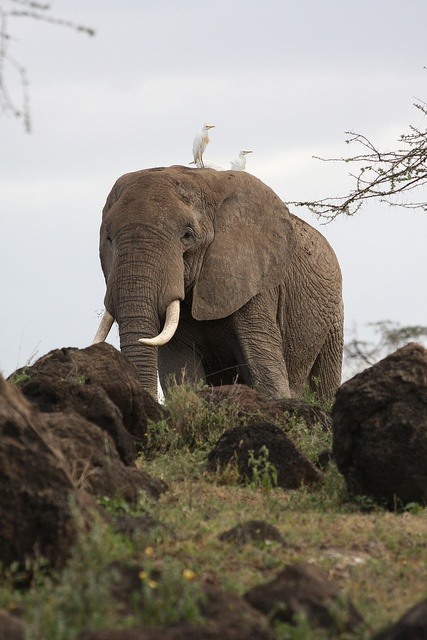Describe the objects in this image and their specific colors. I can see elephant in lightgray, gray, and black tones, bird in lightgray, darkgray, and tan tones, and bird in lightgray, darkgray, and tan tones in this image. 